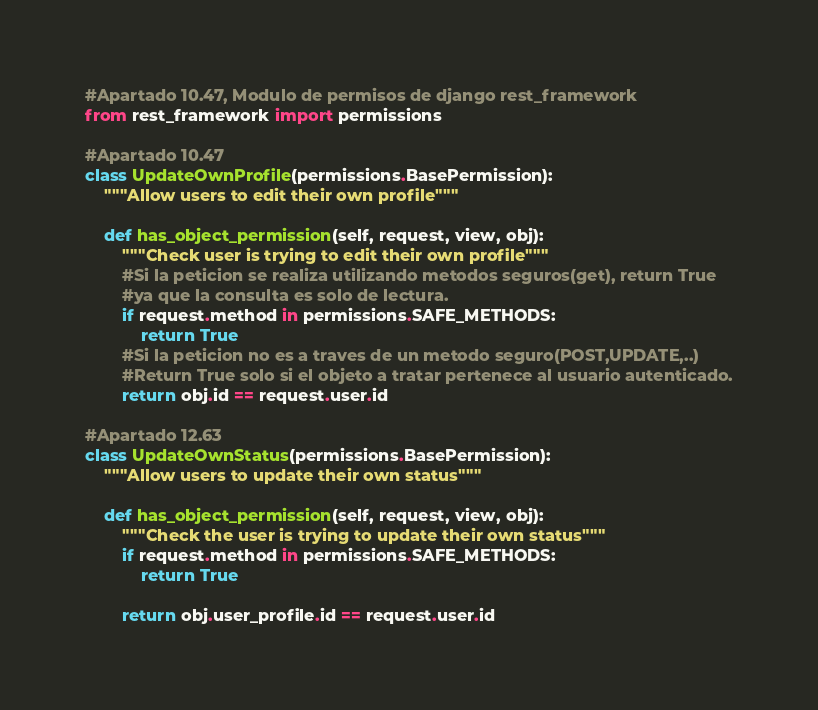Convert code to text. <code><loc_0><loc_0><loc_500><loc_500><_Python_>#Apartado 10.47, Modulo de permisos de django rest_framework
from rest_framework import permissions

#Apartado 10.47
class UpdateOwnProfile(permissions.BasePermission):
    """Allow users to edit their own profile"""

    def has_object_permission(self, request, view, obj):
        """Check user is trying to edit their own profile"""
        #Si la peticion se realiza utilizando metodos seguros(get), return True
        #ya que la consulta es solo de lectura.
        if request.method in permissions.SAFE_METHODS:
            return True
        #Si la peticion no es a traves de un metodo seguro(POST,UPDATE,..)
        #Return True solo si el objeto a tratar pertenece al usuario autenticado.
        return obj.id == request.user.id

#Apartado 12.63
class UpdateOwnStatus(permissions.BasePermission):
    """Allow users to update their own status"""

    def has_object_permission(self, request, view, obj):
        """Check the user is trying to update their own status"""
        if request.method in permissions.SAFE_METHODS:
            return True

        return obj.user_profile.id == request.user.id
</code> 